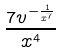<formula> <loc_0><loc_0><loc_500><loc_500>\frac { 7 v ^ { - \frac { 1 } { x ^ { 7 } } } } { x ^ { 4 } }</formula> 